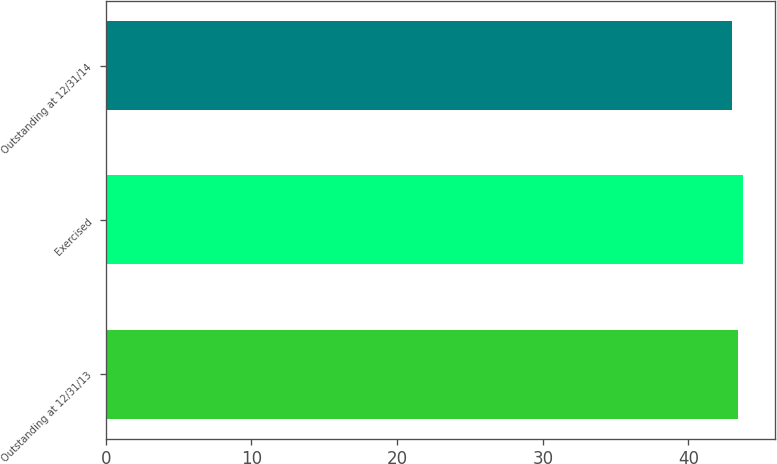<chart> <loc_0><loc_0><loc_500><loc_500><bar_chart><fcel>Outstanding at 12/31/13<fcel>Exercised<fcel>Outstanding at 12/31/14<nl><fcel>43.38<fcel>43.75<fcel>42.99<nl></chart> 